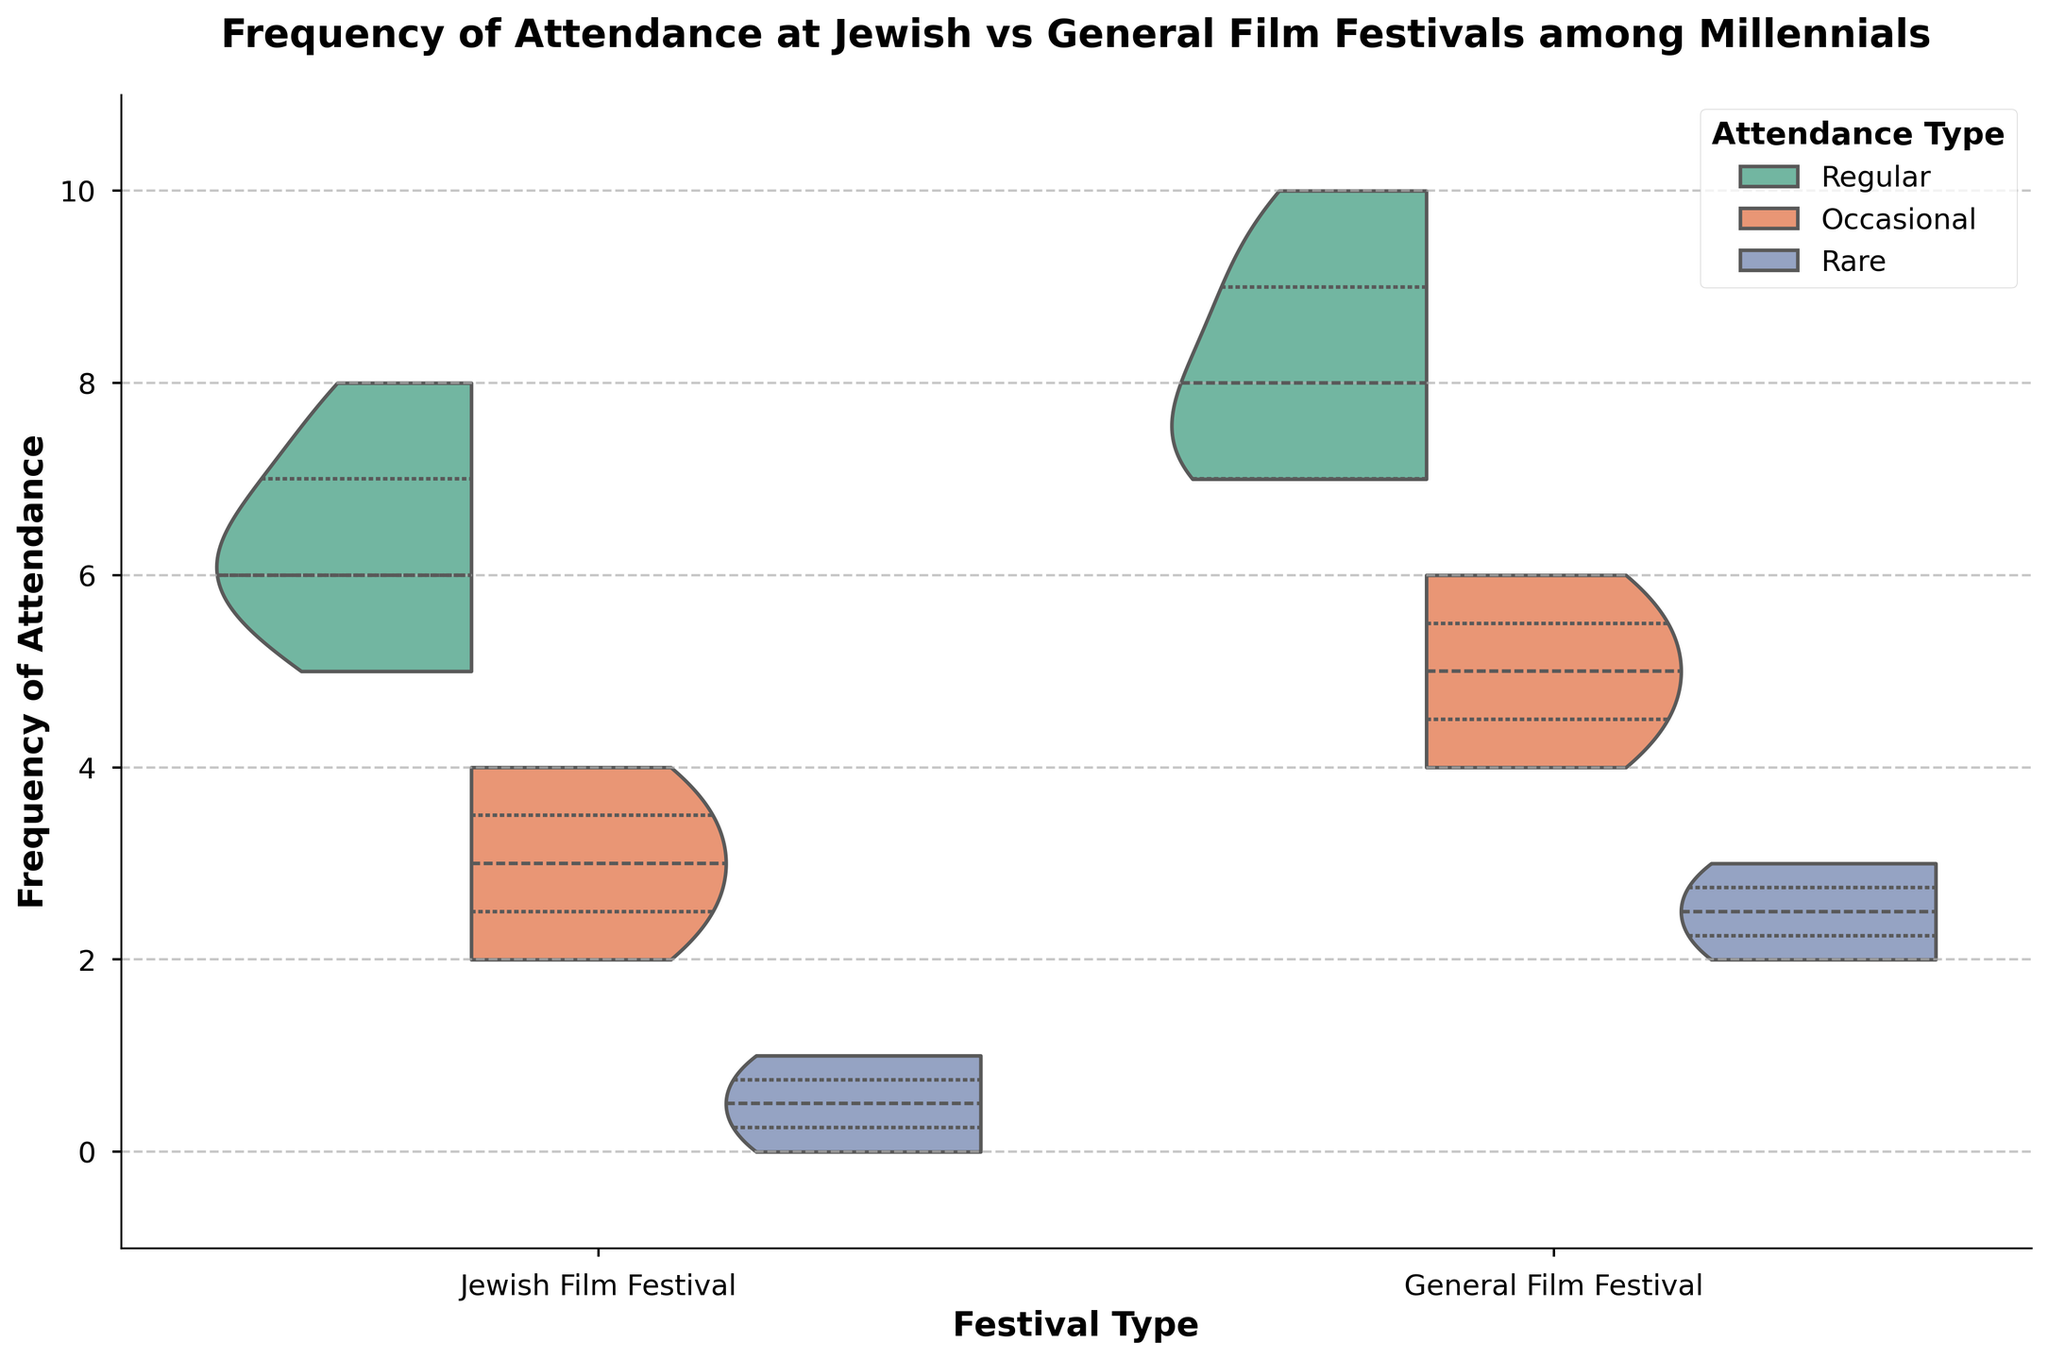Which festival has the higher median frequency for regular attendance? On the split violin plot, we look for the thick white line that represents the median. The Jewish Film Festival has a median around 6 or 7 for regular attendance, while the General Film Festival appears higher around 8 or 9.
Answer: General Film Festival What is the title of the plot? Observing the top of the figure, it clearly states the title.
Answer: Frequency of Attendance at Jewish vs General Film Festivals among Millennials What's the maximum frequency visible for Jewish Film Festival regular attendees? By looking at the vertical axis for the Jewish Film Festival's regular attendance section of the plot, the tallest point reaches up to 8.
Answer: 8 How do the attendance frequencies of occasional attendees at Jewish Film Festivals compare to those at General Film Festivals? The split violin plot shows the distribution of frequencies. Occasional attendees at Jewish Film Festivals mostly range 2 to 4, while at General Film Festivals they range from about 4 to 6. Thus, General Film Festivals have higher frequencies for occasional attendees.
Answer: Jewish Film Festivals occasional attendees have lower frequencies compared to General Film Festivals occasional attendees Which festival has a wider range of attendance frequencies among rare attendees? By comparing the range of values between the rare attendees of both festivals on the split violin plots, Jewish Film Festival ranges from 0 to 1, while General Film Festival ranges from 2 to 3.
Answer: General Film Festival What's the range of frequency values for regular attendees at General Film Festivals? The split violin plot shows a range of regular attendance frequencies for the General Film Festival from 7 to 10.
Answer: 7 to 10 Which attendance type has the highest variability in Jewish Film Festivals? Looking at the spread (width) of the violin plot for each attendance type at the Jewish Film Festival, regular attendance shows the widest spread.
Answer: Regular What is the lower quartile (25th percentile) for regular attendees in General Film Festivals? In the split violin plot, the lower quartile is shown by one of the inner white lines. For General Film Festivals' regular attendees, it appears around 8.
Answer: 8 